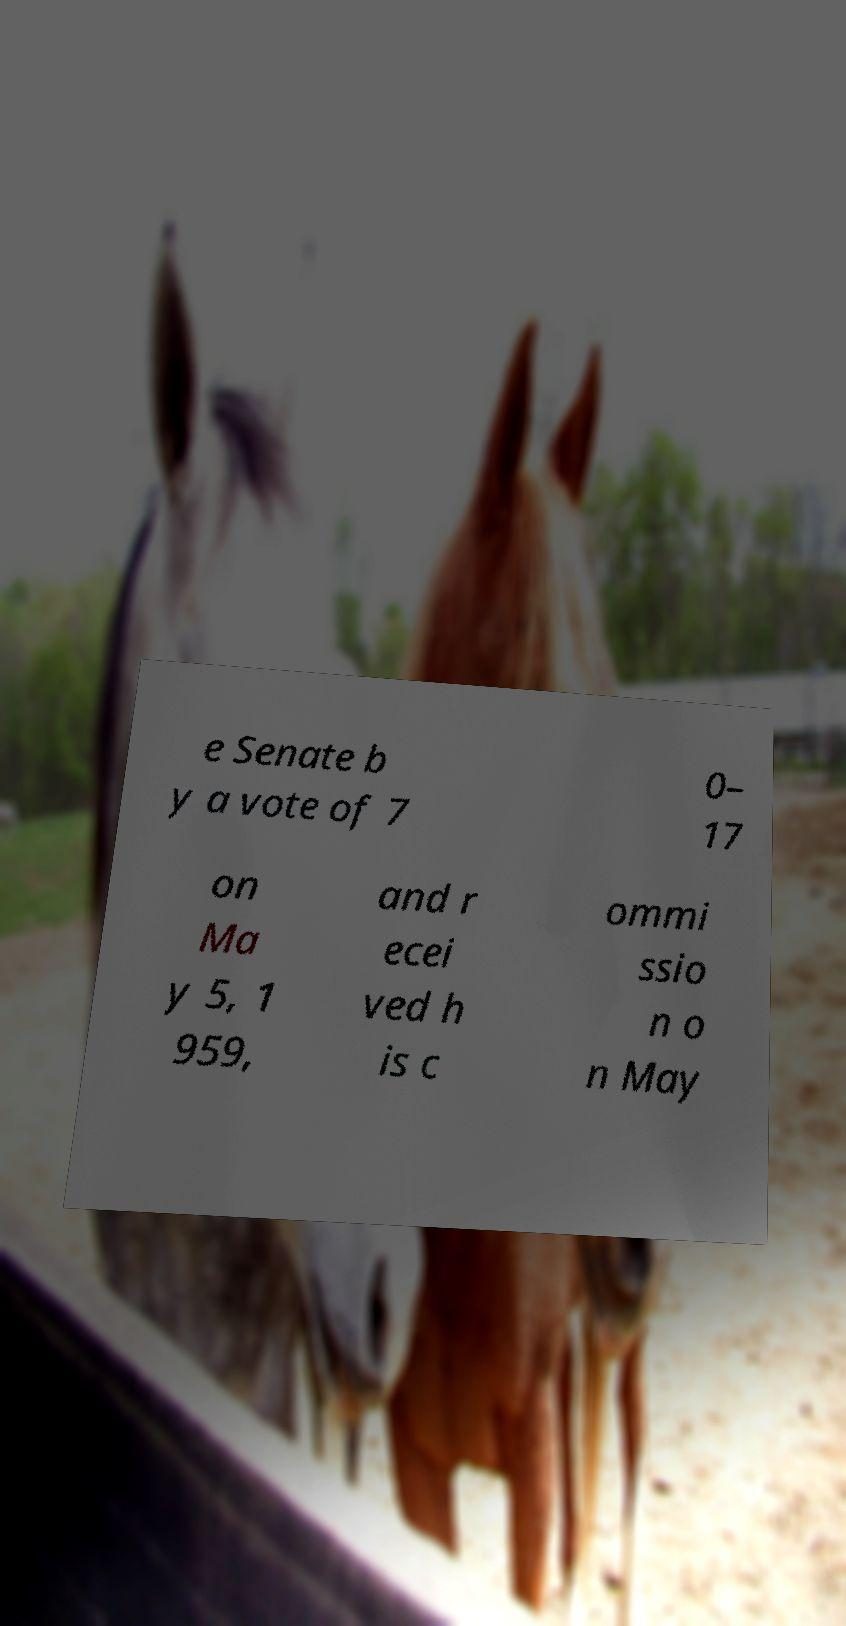What messages or text are displayed in this image? I need them in a readable, typed format. e Senate b y a vote of 7 0– 17 on Ma y 5, 1 959, and r ecei ved h is c ommi ssio n o n May 